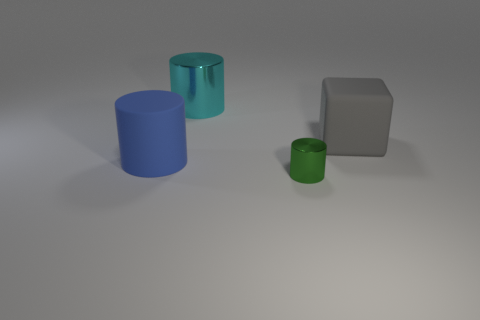Subtract all metallic cylinders. How many cylinders are left? 1 Add 2 cyan cylinders. How many objects exist? 6 Subtract 1 cylinders. How many cylinders are left? 2 Add 3 large cyan shiny things. How many large cyan shiny things are left? 4 Add 2 gray metal cylinders. How many gray metal cylinders exist? 2 Subtract all blue cylinders. How many cylinders are left? 2 Subtract 1 gray blocks. How many objects are left? 3 Subtract all cylinders. How many objects are left? 1 Subtract all brown cubes. Subtract all yellow spheres. How many cubes are left? 1 Subtract all brown spheres. How many purple cubes are left? 0 